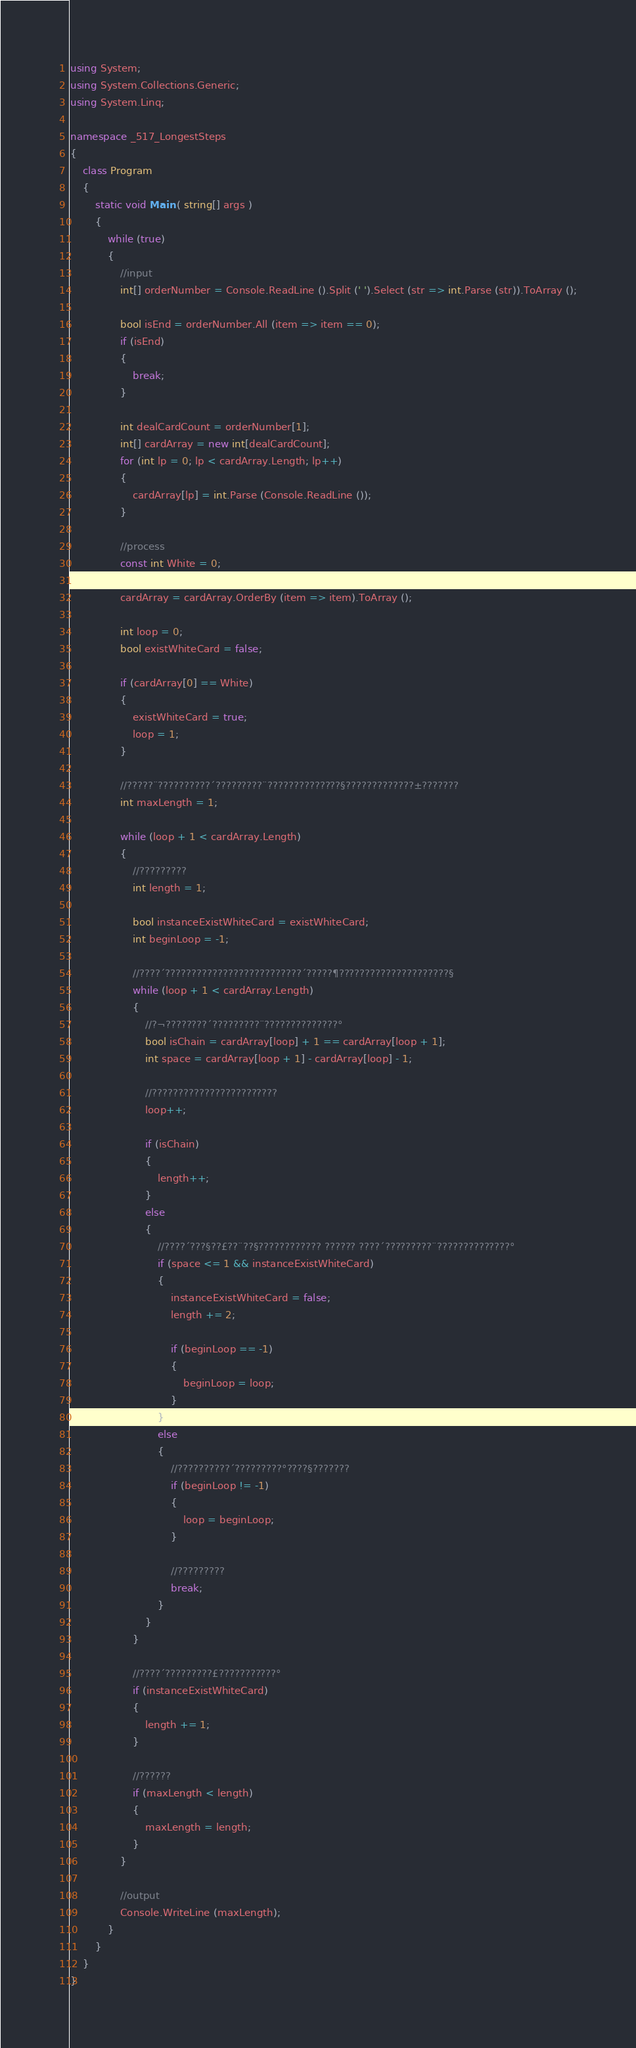Convert code to text. <code><loc_0><loc_0><loc_500><loc_500><_C#_>using System;
using System.Collections.Generic;
using System.Linq;

namespace _517_LongestSteps
{
	class Program
	{
		static void Main ( string[] args )
		{
			while (true)
			{
				//input
				int[] orderNumber = Console.ReadLine ().Split (' ').Select (str => int.Parse (str)).ToArray ();

				bool isEnd = orderNumber.All (item => item == 0);
				if (isEnd)
				{
					break;
				}

				int dealCardCount = orderNumber[1];
				int[] cardArray = new int[dealCardCount];
				for (int lp = 0; lp < cardArray.Length; lp++)
				{
					cardArray[lp] = int.Parse (Console.ReadLine ());
				}

				//process
				const int White = 0;

				cardArray = cardArray.OrderBy (item => item).ToArray ();

				int loop = 0;
				bool existWhiteCard = false;

				if (cardArray[0] == White)
				{
					existWhiteCard = true;
					loop = 1;
				}
			
				//?????¨??????????´?????????¨??????????????§?????????????±???????
				int maxLength = 1;

				while (loop + 1 < cardArray.Length)
				{
					//?????????
					int length = 1;

					bool instanceExistWhiteCard = existWhiteCard;
					int beginLoop = -1;

					//????´??????????????????????????´?????¶?????????????????????§
					while (loop + 1 < cardArray.Length)
					{
						//?¬????????´?????????¨??????????????°
						bool isChain = cardArray[loop] + 1 == cardArray[loop + 1];
						int space = cardArray[loop + 1] - cardArray[loop] - 1;

						//????????????????????????
						loop++;

						if (isChain)
						{
							length++;
						}
						else
						{
							//????´???§??£??¨??§???????????? ?????? ????´?????????¨??????????????°
							if (space <= 1 && instanceExistWhiteCard)
							{
								instanceExistWhiteCard = false;
								length += 2;

								if (beginLoop == -1)
								{
									beginLoop = loop;
								}
							}
							else
							{
								//??????????´?????????°????§???????
								if (beginLoop != -1)
								{
									loop = beginLoop;
								}

								//?????????
								break;
							}
						}
					}

					//????´?????????£???????????°
					if (instanceExistWhiteCard)
					{
						length += 1;
					}

					//??????
					if (maxLength < length)
					{
						maxLength = length;
					}
				}

				//output
				Console.WriteLine (maxLength);
			}
		}
	}
}</code> 